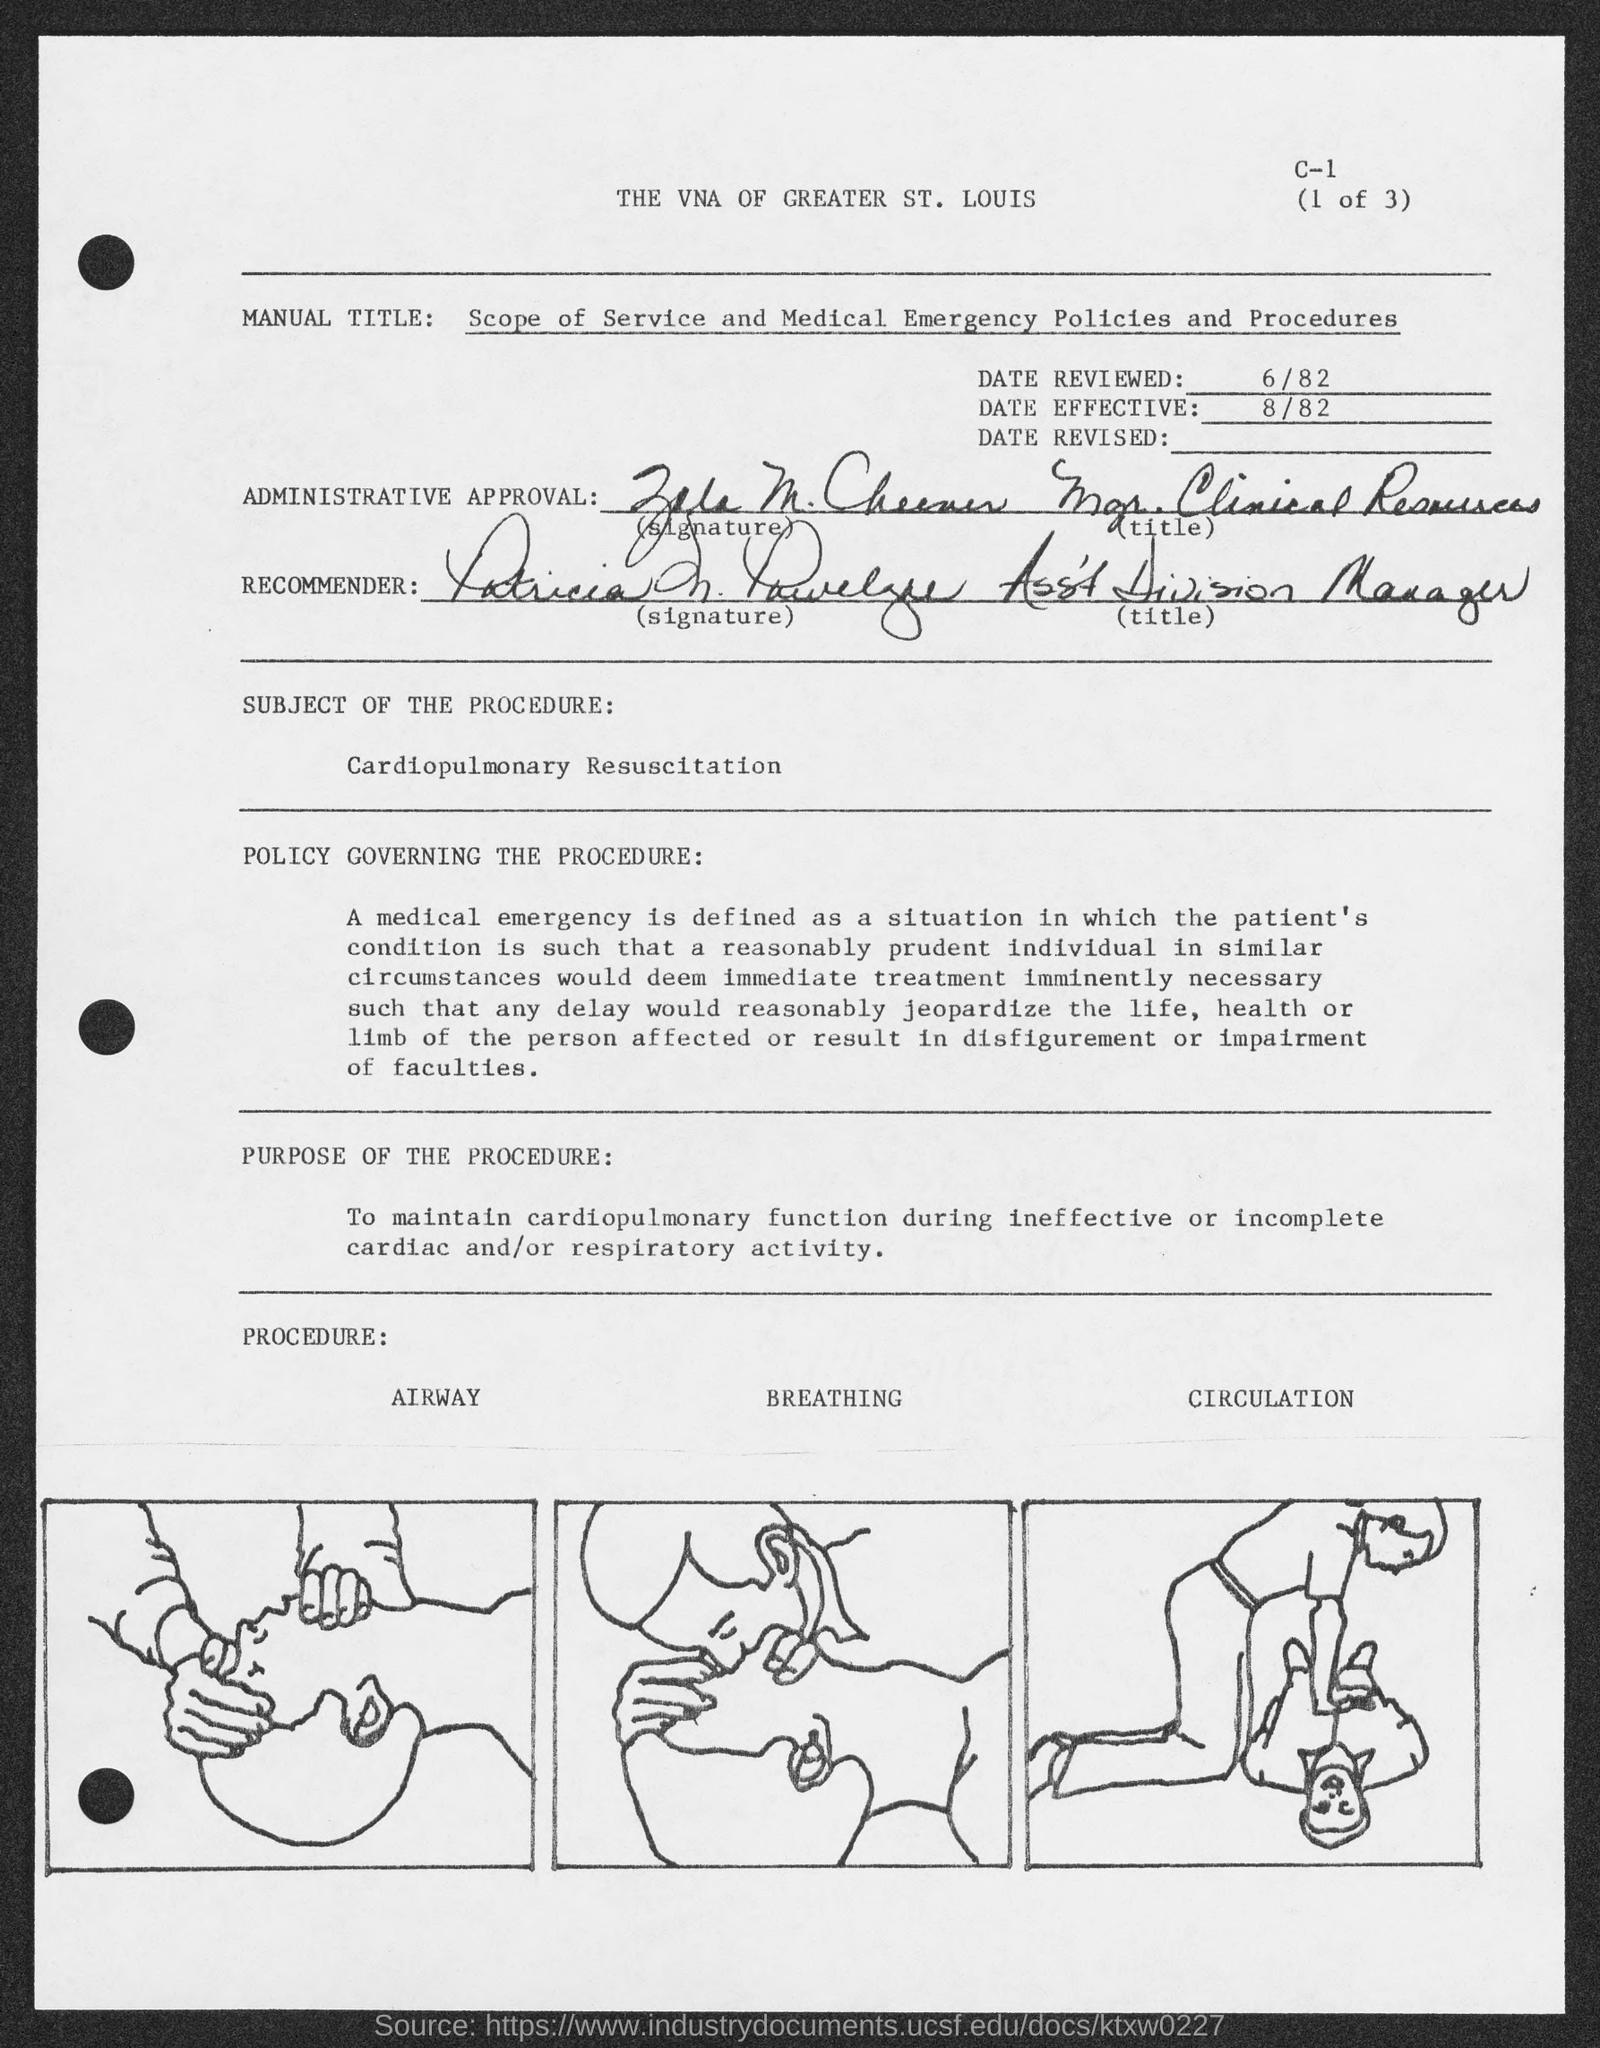What is the Date reviewed?
Give a very brief answer. 6/82. What is the Date effective?
Keep it short and to the point. 8/82. What is the Title of the document?
Provide a short and direct response. The VNA of greater St. Louis. 